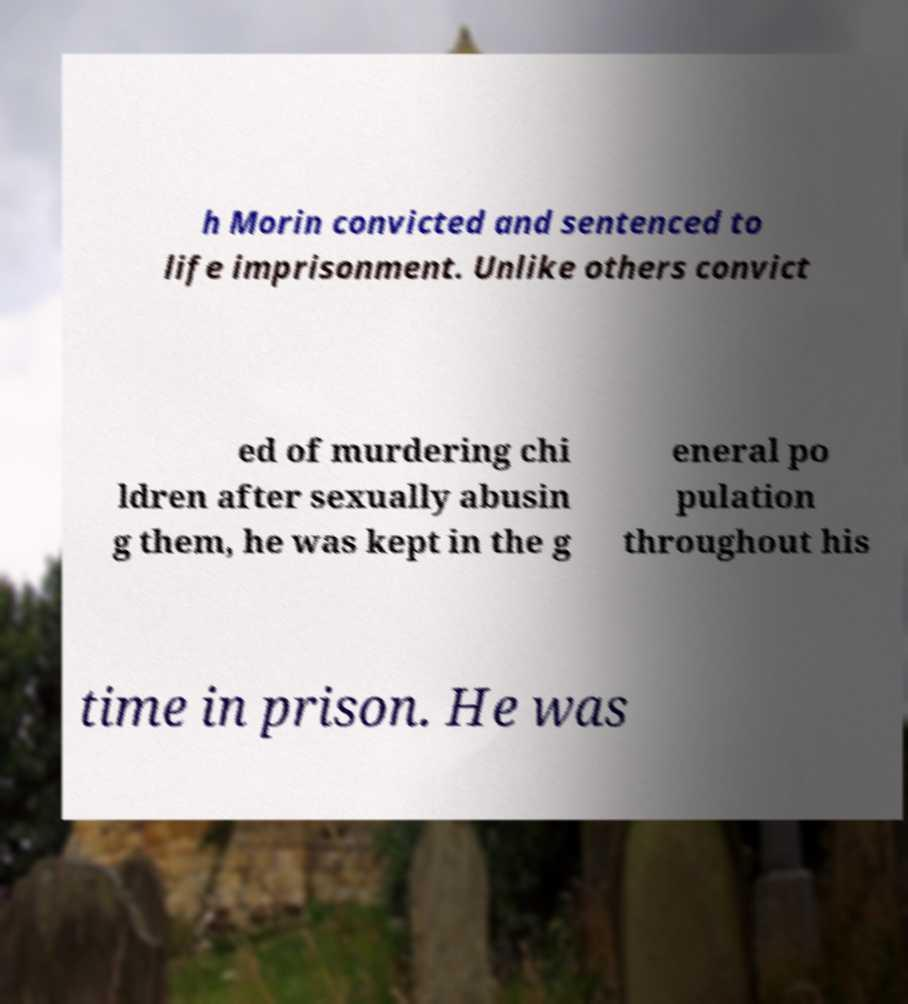Can you read and provide the text displayed in the image?This photo seems to have some interesting text. Can you extract and type it out for me? h Morin convicted and sentenced to life imprisonment. Unlike others convict ed of murdering chi ldren after sexually abusin g them, he was kept in the g eneral po pulation throughout his time in prison. He was 